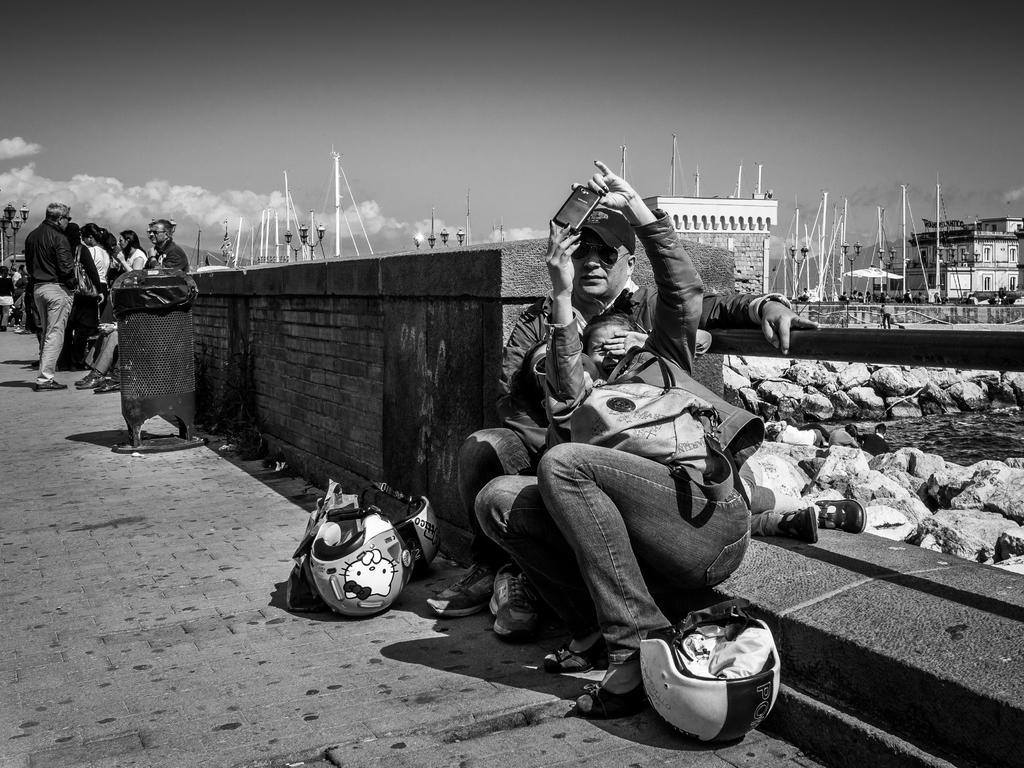Could you give a brief overview of what you see in this image? In this image I can see 2 people sitting in the front. A person is holding a mobile phone. There are helmets. There is a wall behind them. There are other people at the back. There are buildings and poles at the back. This is a black and white image. 